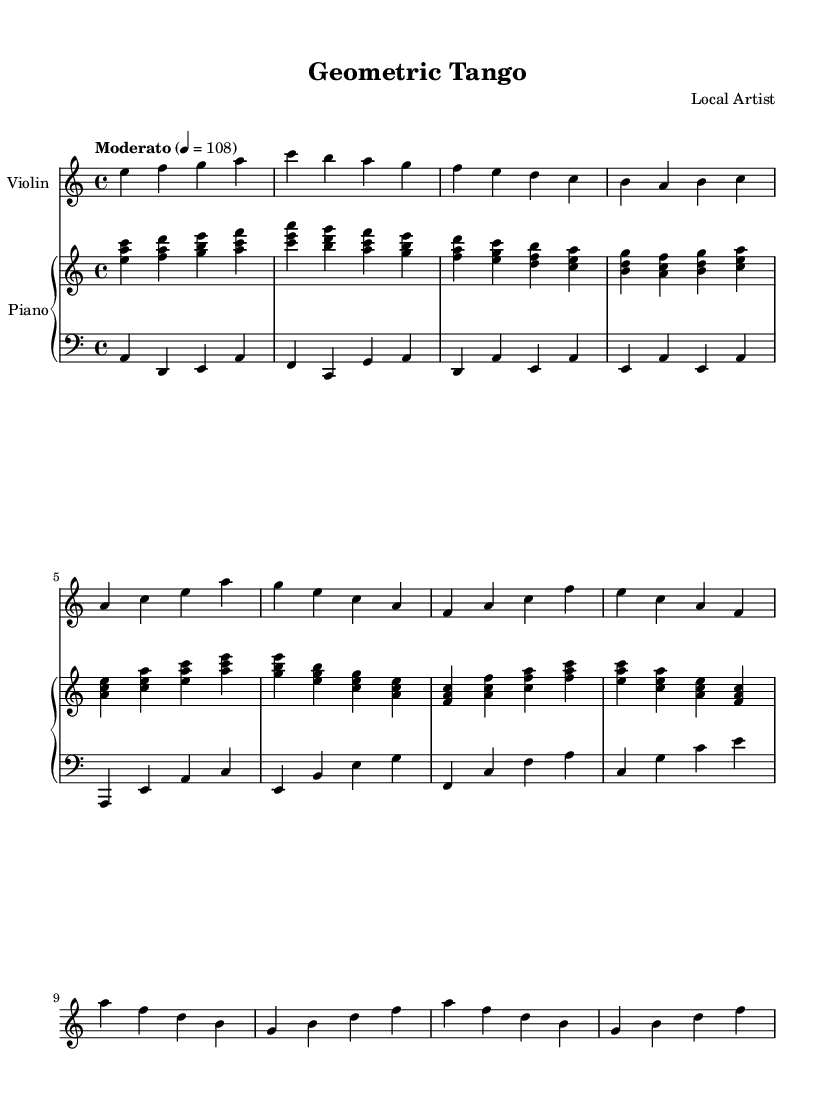What is the key signature of this music? The music is in A minor, which has no sharps or flats. This is identified by the key signature placed at the beginning of the staff.
Answer: A minor What is the time signature of this composition? The time signature is 4/4, indicated by the fraction placed at the beginning of the score, suggesting that there are four beats in a measure.
Answer: 4/4 What is the tempo marking for this piece? The tempo marking is "Moderato," which indicates a moderate pace are typically around 108 beats per minute, specified in the score at the start of the music.
Answer: Moderato How many measures are in the A Section? The A Section consists of 8 measures, identifiable by counting the distinct groupings of notes and rests as specified in the sheet music.
Answer: 8 measures What geometric principle is reflected in the B Section? The B Section features a mirrored melody, showcasing symmetry, where the melodic line is replicated in reverse order but retains similar intervals.
Answer: Symmetry Is there a use of a harmonic progression that reflects the Golden Ratio in this composition? Yes, the chord changes in this composition could be analyzed to find patterns that align with the Golden Ratio, especially in the relationship of the sections and transitions. However, identifying this precisely would require deeper analysis beyond just visual inspection of the score.
Answer: Yes What element of Latin music is prominently featured in this composition? The syncopation and rhythmic structure typical of tango music is a key element, which is evident through the combination of the violin and piano parts, designed to create a danceable feel.
Answer: Syncopation 